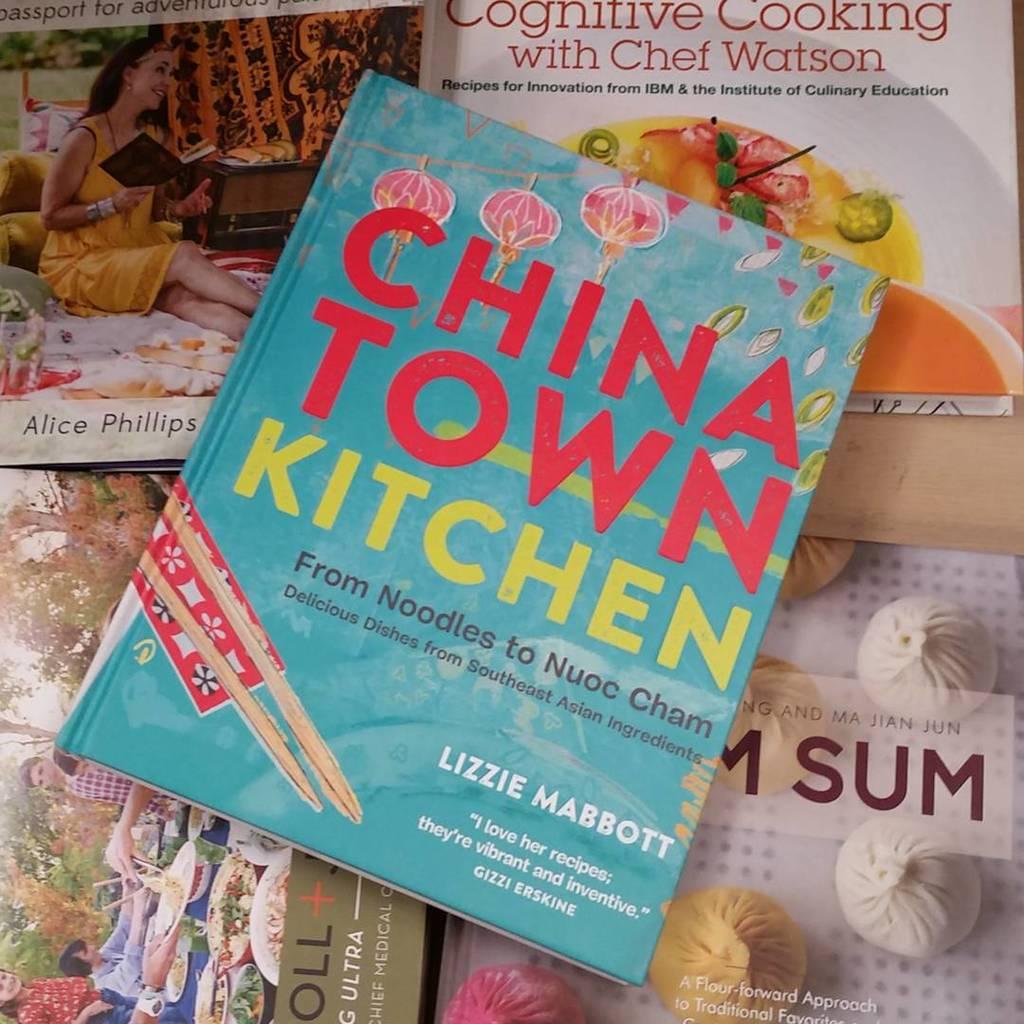<image>
Create a compact narrative representing the image presented. China town kitchen from noodles to nuoc cham book on top of other cooking books 